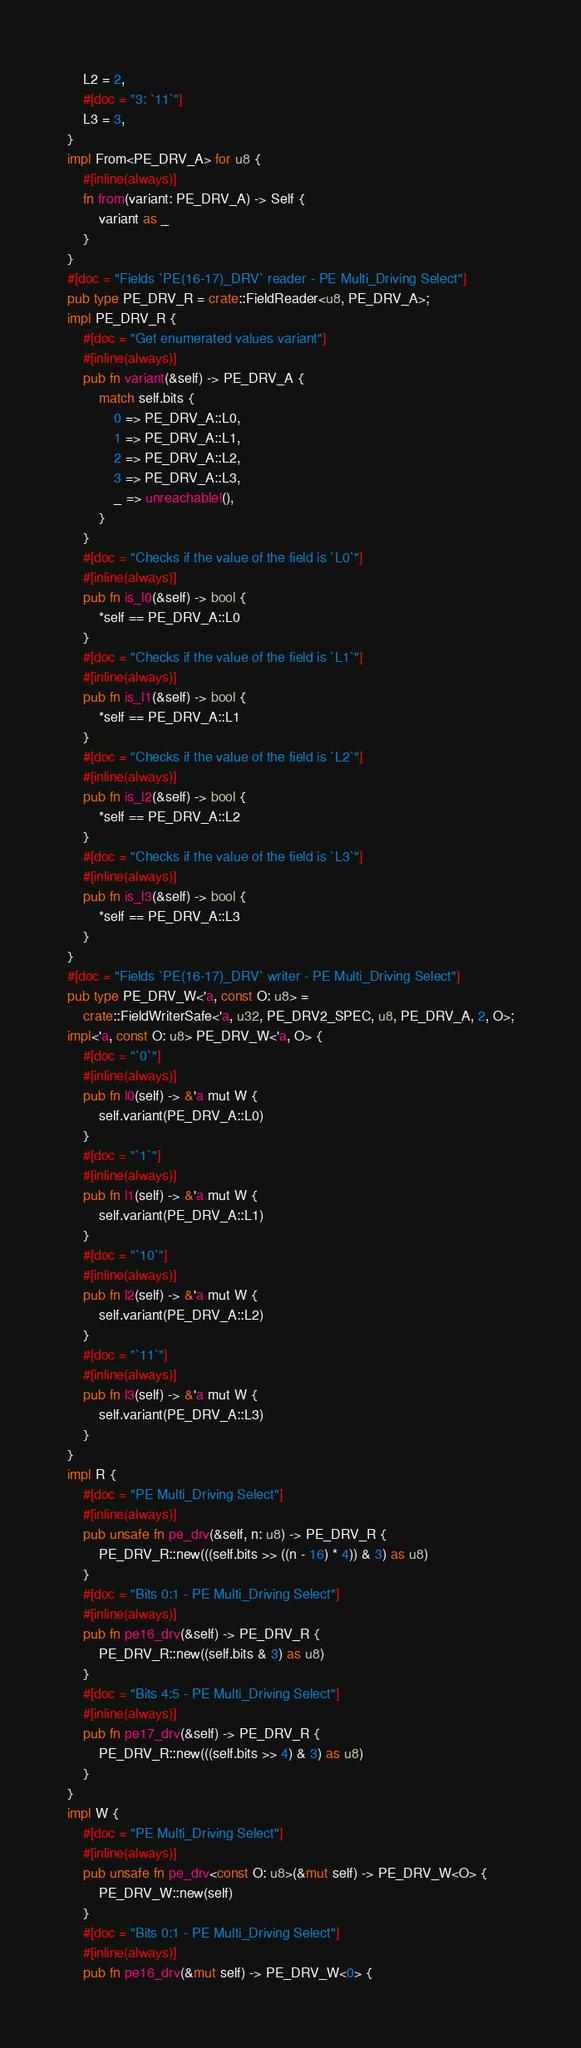Convert code to text. <code><loc_0><loc_0><loc_500><loc_500><_Rust_>    L2 = 2,
    #[doc = "3: `11`"]
    L3 = 3,
}
impl From<PE_DRV_A> for u8 {
    #[inline(always)]
    fn from(variant: PE_DRV_A) -> Self {
        variant as _
    }
}
#[doc = "Fields `PE(16-17)_DRV` reader - PE Multi_Driving Select"]
pub type PE_DRV_R = crate::FieldReader<u8, PE_DRV_A>;
impl PE_DRV_R {
    #[doc = "Get enumerated values variant"]
    #[inline(always)]
    pub fn variant(&self) -> PE_DRV_A {
        match self.bits {
            0 => PE_DRV_A::L0,
            1 => PE_DRV_A::L1,
            2 => PE_DRV_A::L2,
            3 => PE_DRV_A::L3,
            _ => unreachable!(),
        }
    }
    #[doc = "Checks if the value of the field is `L0`"]
    #[inline(always)]
    pub fn is_l0(&self) -> bool {
        *self == PE_DRV_A::L0
    }
    #[doc = "Checks if the value of the field is `L1`"]
    #[inline(always)]
    pub fn is_l1(&self) -> bool {
        *self == PE_DRV_A::L1
    }
    #[doc = "Checks if the value of the field is `L2`"]
    #[inline(always)]
    pub fn is_l2(&self) -> bool {
        *self == PE_DRV_A::L2
    }
    #[doc = "Checks if the value of the field is `L3`"]
    #[inline(always)]
    pub fn is_l3(&self) -> bool {
        *self == PE_DRV_A::L3
    }
}
#[doc = "Fields `PE(16-17)_DRV` writer - PE Multi_Driving Select"]
pub type PE_DRV_W<'a, const O: u8> =
    crate::FieldWriterSafe<'a, u32, PE_DRV2_SPEC, u8, PE_DRV_A, 2, O>;
impl<'a, const O: u8> PE_DRV_W<'a, O> {
    #[doc = "`0`"]
    #[inline(always)]
    pub fn l0(self) -> &'a mut W {
        self.variant(PE_DRV_A::L0)
    }
    #[doc = "`1`"]
    #[inline(always)]
    pub fn l1(self) -> &'a mut W {
        self.variant(PE_DRV_A::L1)
    }
    #[doc = "`10`"]
    #[inline(always)]
    pub fn l2(self) -> &'a mut W {
        self.variant(PE_DRV_A::L2)
    }
    #[doc = "`11`"]
    #[inline(always)]
    pub fn l3(self) -> &'a mut W {
        self.variant(PE_DRV_A::L3)
    }
}
impl R {
    #[doc = "PE Multi_Driving Select"]
    #[inline(always)]
    pub unsafe fn pe_drv(&self, n: u8) -> PE_DRV_R {
        PE_DRV_R::new(((self.bits >> ((n - 16) * 4)) & 3) as u8)
    }
    #[doc = "Bits 0:1 - PE Multi_Driving Select"]
    #[inline(always)]
    pub fn pe16_drv(&self) -> PE_DRV_R {
        PE_DRV_R::new((self.bits & 3) as u8)
    }
    #[doc = "Bits 4:5 - PE Multi_Driving Select"]
    #[inline(always)]
    pub fn pe17_drv(&self) -> PE_DRV_R {
        PE_DRV_R::new(((self.bits >> 4) & 3) as u8)
    }
}
impl W {
    #[doc = "PE Multi_Driving Select"]
    #[inline(always)]
    pub unsafe fn pe_drv<const O: u8>(&mut self) -> PE_DRV_W<O> {
        PE_DRV_W::new(self)
    }
    #[doc = "Bits 0:1 - PE Multi_Driving Select"]
    #[inline(always)]
    pub fn pe16_drv(&mut self) -> PE_DRV_W<0> {</code> 